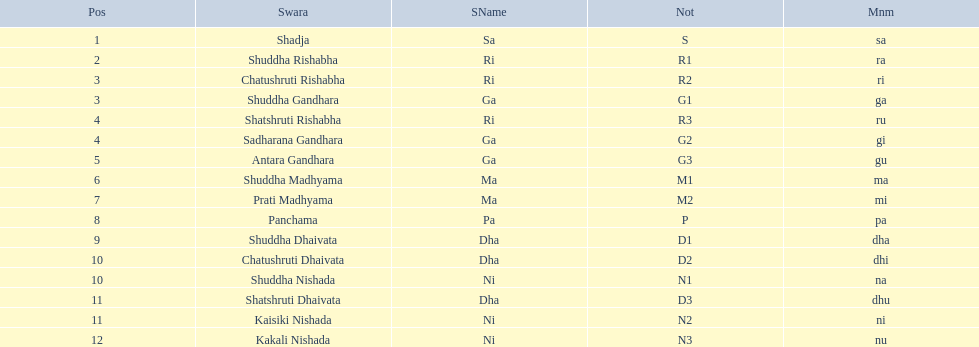How many swaras do not have dhaivata in their name? 13. 